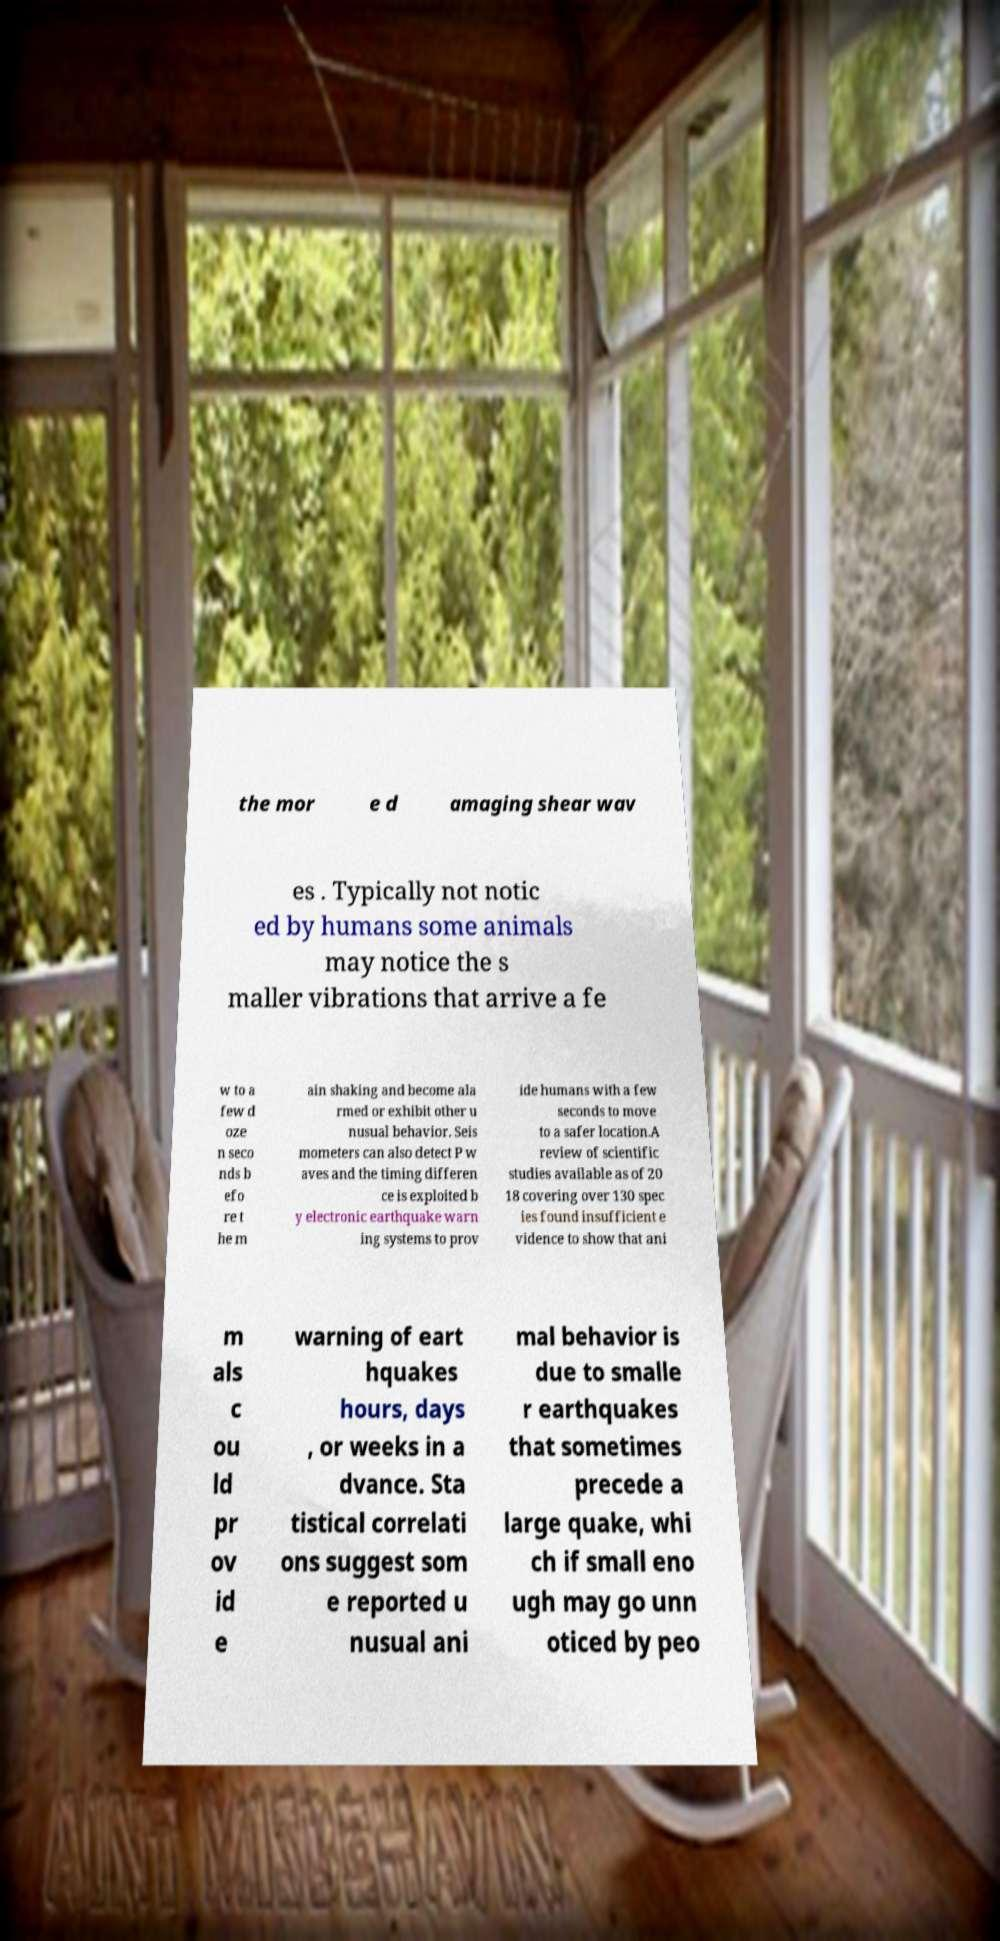Can you accurately transcribe the text from the provided image for me? the mor e d amaging shear wav es . Typically not notic ed by humans some animals may notice the s maller vibrations that arrive a fe w to a few d oze n seco nds b efo re t he m ain shaking and become ala rmed or exhibit other u nusual behavior. Seis mometers can also detect P w aves and the timing differen ce is exploited b y electronic earthquake warn ing systems to prov ide humans with a few seconds to move to a safer location.A review of scientific studies available as of 20 18 covering over 130 spec ies found insufficient e vidence to show that ani m als c ou ld pr ov id e warning of eart hquakes hours, days , or weeks in a dvance. Sta tistical correlati ons suggest som e reported u nusual ani mal behavior is due to smalle r earthquakes that sometimes precede a large quake, whi ch if small eno ugh may go unn oticed by peo 